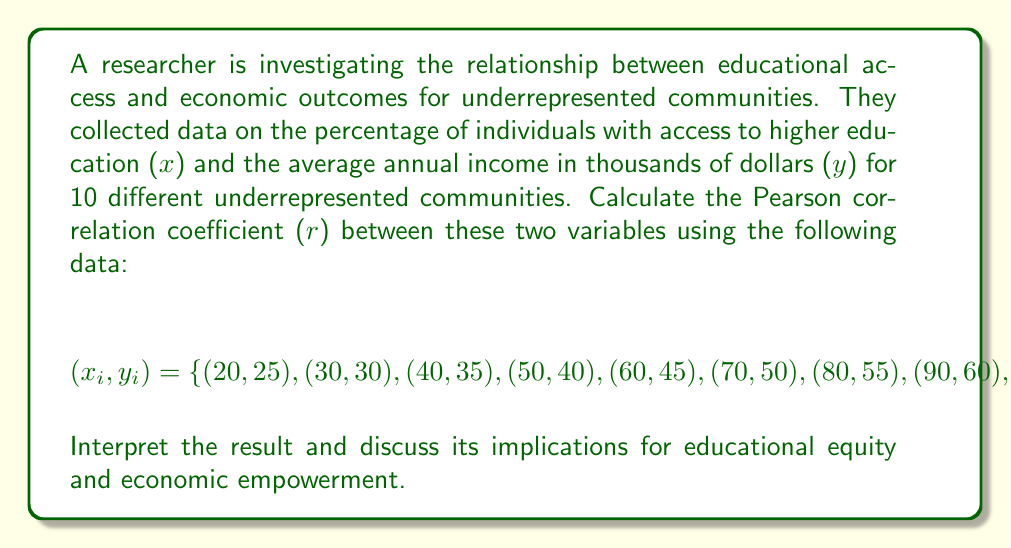Teach me how to tackle this problem. To calculate the Pearson correlation coefficient (r), we'll use the formula:

$$r = \frac{\sum_{i=1}^{n} (x_i - \bar{x})(y_i - \bar{y})}{\sqrt{\sum_{i=1}^{n} (x_i - \bar{x})^2} \sqrt{\sum_{i=1}^{n} (y_i - \bar{y})^2}}$$

Step 1: Calculate the means $\bar{x}$ and $\bar{y}$
$\bar{x} = \frac{20 + 30 + 40 + 50 + 60 + 70 + 80 + 90 + 25 + 35}{10} = 50$
$\bar{y} = \frac{25 + 30 + 35 + 40 + 45 + 50 + 55 + 60 + 28 + 32}{10} = 40$

Step 2: Calculate $(x_i - \bar{x})$, $(y_i - \bar{y})$, $(x_i - \bar{x})^2$, $(y_i - \bar{y})^2$, and $(x_i - \bar{x})(y_i - \bar{y})$ for each pair

Step 3: Sum the results
$\sum (x_i - \bar{x})(y_i - \bar{y}) = 2375$
$\sum (x_i - \bar{x})^2 = 5875$
$\sum (y_i - \bar{y})^2 = 1260$

Step 4: Apply the formula
$$r = \frac{2375}{\sqrt{5875} \sqrt{1260}} \approx 0.9798$$

Interpretation: The Pearson correlation coefficient of approximately 0.9798 indicates a very strong positive correlation between educational access and economic outcomes for underrepresented communities. This suggests that as access to higher education increases, average annual income tends to increase as well.

Implications: This strong correlation highlights the importance of improving educational access for underrepresented communities as a means of promoting economic empowerment and reducing income disparities. Policymakers and educators should focus on initiatives that increase educational opportunities for these communities to potentially improve their economic outcomes and overall quality of life.
Answer: $r \approx 0.9798$ 